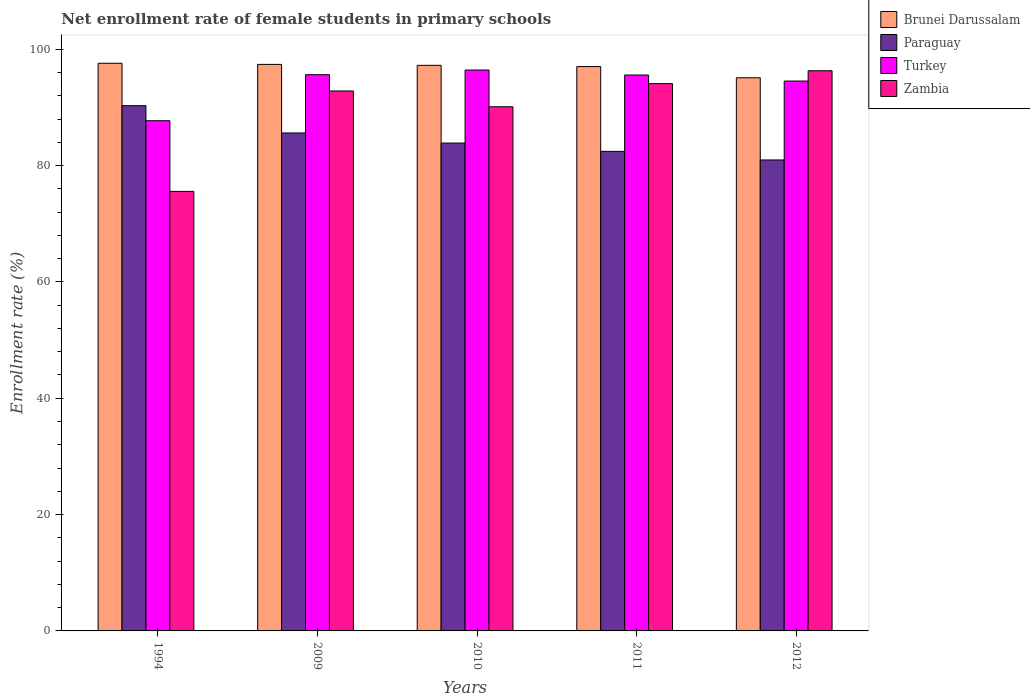How many different coloured bars are there?
Make the answer very short. 4. How many bars are there on the 2nd tick from the left?
Ensure brevity in your answer.  4. How many bars are there on the 4th tick from the right?
Offer a terse response. 4. What is the label of the 4th group of bars from the left?
Give a very brief answer. 2011. In how many cases, is the number of bars for a given year not equal to the number of legend labels?
Keep it short and to the point. 0. What is the net enrollment rate of female students in primary schools in Brunei Darussalam in 2011?
Your response must be concise. 97.02. Across all years, what is the maximum net enrollment rate of female students in primary schools in Zambia?
Your answer should be compact. 96.3. Across all years, what is the minimum net enrollment rate of female students in primary schools in Turkey?
Provide a succinct answer. 87.71. In which year was the net enrollment rate of female students in primary schools in Paraguay maximum?
Your answer should be compact. 1994. What is the total net enrollment rate of female students in primary schools in Brunei Darussalam in the graph?
Keep it short and to the point. 484.35. What is the difference between the net enrollment rate of female students in primary schools in Zambia in 2009 and that in 2010?
Keep it short and to the point. 2.72. What is the difference between the net enrollment rate of female students in primary schools in Zambia in 2010 and the net enrollment rate of female students in primary schools in Brunei Darussalam in 2009?
Provide a succinct answer. -7.28. What is the average net enrollment rate of female students in primary schools in Brunei Darussalam per year?
Ensure brevity in your answer.  96.87. In the year 2012, what is the difference between the net enrollment rate of female students in primary schools in Turkey and net enrollment rate of female students in primary schools in Zambia?
Your response must be concise. -1.77. In how many years, is the net enrollment rate of female students in primary schools in Paraguay greater than 12 %?
Your answer should be compact. 5. What is the ratio of the net enrollment rate of female students in primary schools in Brunei Darussalam in 2011 to that in 2012?
Offer a very short reply. 1.02. What is the difference between the highest and the second highest net enrollment rate of female students in primary schools in Paraguay?
Your answer should be compact. 4.69. What is the difference between the highest and the lowest net enrollment rate of female students in primary schools in Turkey?
Provide a short and direct response. 8.72. In how many years, is the net enrollment rate of female students in primary schools in Brunei Darussalam greater than the average net enrollment rate of female students in primary schools in Brunei Darussalam taken over all years?
Offer a terse response. 4. Is the sum of the net enrollment rate of female students in primary schools in Zambia in 1994 and 2010 greater than the maximum net enrollment rate of female students in primary schools in Brunei Darussalam across all years?
Provide a succinct answer. Yes. Is it the case that in every year, the sum of the net enrollment rate of female students in primary schools in Turkey and net enrollment rate of female students in primary schools in Zambia is greater than the sum of net enrollment rate of female students in primary schools in Paraguay and net enrollment rate of female students in primary schools in Brunei Darussalam?
Offer a very short reply. No. What does the 4th bar from the left in 2009 represents?
Offer a very short reply. Zambia. What does the 2nd bar from the right in 2010 represents?
Provide a succinct answer. Turkey. How many bars are there?
Provide a short and direct response. 20. Are all the bars in the graph horizontal?
Give a very brief answer. No. Does the graph contain any zero values?
Ensure brevity in your answer.  No. Does the graph contain grids?
Offer a very short reply. No. Where does the legend appear in the graph?
Ensure brevity in your answer.  Top right. How many legend labels are there?
Provide a succinct answer. 4. What is the title of the graph?
Make the answer very short. Net enrollment rate of female students in primary schools. Does "Kuwait" appear as one of the legend labels in the graph?
Offer a terse response. No. What is the label or title of the X-axis?
Offer a terse response. Years. What is the label or title of the Y-axis?
Give a very brief answer. Enrollment rate (%). What is the Enrollment rate (%) in Brunei Darussalam in 1994?
Offer a terse response. 97.59. What is the Enrollment rate (%) in Paraguay in 1994?
Your answer should be compact. 90.3. What is the Enrollment rate (%) in Turkey in 1994?
Your response must be concise. 87.71. What is the Enrollment rate (%) in Zambia in 1994?
Your response must be concise. 75.57. What is the Enrollment rate (%) in Brunei Darussalam in 2009?
Make the answer very short. 97.4. What is the Enrollment rate (%) of Paraguay in 2009?
Make the answer very short. 85.61. What is the Enrollment rate (%) in Turkey in 2009?
Give a very brief answer. 95.63. What is the Enrollment rate (%) in Zambia in 2009?
Offer a terse response. 92.83. What is the Enrollment rate (%) in Brunei Darussalam in 2010?
Offer a terse response. 97.24. What is the Enrollment rate (%) in Paraguay in 2010?
Ensure brevity in your answer.  83.87. What is the Enrollment rate (%) in Turkey in 2010?
Ensure brevity in your answer.  96.43. What is the Enrollment rate (%) of Zambia in 2010?
Offer a terse response. 90.11. What is the Enrollment rate (%) in Brunei Darussalam in 2011?
Offer a terse response. 97.02. What is the Enrollment rate (%) in Paraguay in 2011?
Ensure brevity in your answer.  82.44. What is the Enrollment rate (%) in Turkey in 2011?
Offer a terse response. 95.57. What is the Enrollment rate (%) in Zambia in 2011?
Provide a short and direct response. 94.09. What is the Enrollment rate (%) of Brunei Darussalam in 2012?
Your answer should be compact. 95.1. What is the Enrollment rate (%) in Paraguay in 2012?
Offer a terse response. 80.97. What is the Enrollment rate (%) in Turkey in 2012?
Keep it short and to the point. 94.53. What is the Enrollment rate (%) in Zambia in 2012?
Keep it short and to the point. 96.3. Across all years, what is the maximum Enrollment rate (%) in Brunei Darussalam?
Give a very brief answer. 97.59. Across all years, what is the maximum Enrollment rate (%) in Paraguay?
Keep it short and to the point. 90.3. Across all years, what is the maximum Enrollment rate (%) of Turkey?
Offer a very short reply. 96.43. Across all years, what is the maximum Enrollment rate (%) in Zambia?
Offer a terse response. 96.3. Across all years, what is the minimum Enrollment rate (%) in Brunei Darussalam?
Your answer should be very brief. 95.1. Across all years, what is the minimum Enrollment rate (%) in Paraguay?
Ensure brevity in your answer.  80.97. Across all years, what is the minimum Enrollment rate (%) of Turkey?
Provide a short and direct response. 87.71. Across all years, what is the minimum Enrollment rate (%) of Zambia?
Provide a succinct answer. 75.57. What is the total Enrollment rate (%) in Brunei Darussalam in the graph?
Offer a very short reply. 484.35. What is the total Enrollment rate (%) of Paraguay in the graph?
Offer a terse response. 423.2. What is the total Enrollment rate (%) in Turkey in the graph?
Provide a succinct answer. 469.87. What is the total Enrollment rate (%) of Zambia in the graph?
Your answer should be very brief. 448.9. What is the difference between the Enrollment rate (%) of Brunei Darussalam in 1994 and that in 2009?
Provide a succinct answer. 0.2. What is the difference between the Enrollment rate (%) of Paraguay in 1994 and that in 2009?
Your answer should be compact. 4.69. What is the difference between the Enrollment rate (%) of Turkey in 1994 and that in 2009?
Your response must be concise. -7.91. What is the difference between the Enrollment rate (%) in Zambia in 1994 and that in 2009?
Provide a succinct answer. -17.26. What is the difference between the Enrollment rate (%) in Brunei Darussalam in 1994 and that in 2010?
Your answer should be very brief. 0.36. What is the difference between the Enrollment rate (%) of Paraguay in 1994 and that in 2010?
Give a very brief answer. 6.43. What is the difference between the Enrollment rate (%) of Turkey in 1994 and that in 2010?
Your response must be concise. -8.72. What is the difference between the Enrollment rate (%) of Zambia in 1994 and that in 2010?
Provide a short and direct response. -14.55. What is the difference between the Enrollment rate (%) of Brunei Darussalam in 1994 and that in 2011?
Your answer should be compact. 0.57. What is the difference between the Enrollment rate (%) in Paraguay in 1994 and that in 2011?
Give a very brief answer. 7.86. What is the difference between the Enrollment rate (%) of Turkey in 1994 and that in 2011?
Your answer should be very brief. -7.86. What is the difference between the Enrollment rate (%) of Zambia in 1994 and that in 2011?
Keep it short and to the point. -18.53. What is the difference between the Enrollment rate (%) of Brunei Darussalam in 1994 and that in 2012?
Your answer should be very brief. 2.49. What is the difference between the Enrollment rate (%) of Paraguay in 1994 and that in 2012?
Make the answer very short. 9.34. What is the difference between the Enrollment rate (%) of Turkey in 1994 and that in 2012?
Give a very brief answer. -6.82. What is the difference between the Enrollment rate (%) in Zambia in 1994 and that in 2012?
Make the answer very short. -20.74. What is the difference between the Enrollment rate (%) of Brunei Darussalam in 2009 and that in 2010?
Keep it short and to the point. 0.16. What is the difference between the Enrollment rate (%) of Paraguay in 2009 and that in 2010?
Your answer should be compact. 1.74. What is the difference between the Enrollment rate (%) in Turkey in 2009 and that in 2010?
Your answer should be very brief. -0.8. What is the difference between the Enrollment rate (%) in Zambia in 2009 and that in 2010?
Your answer should be compact. 2.72. What is the difference between the Enrollment rate (%) of Brunei Darussalam in 2009 and that in 2011?
Your response must be concise. 0.38. What is the difference between the Enrollment rate (%) in Paraguay in 2009 and that in 2011?
Your response must be concise. 3.17. What is the difference between the Enrollment rate (%) in Turkey in 2009 and that in 2011?
Offer a terse response. 0.06. What is the difference between the Enrollment rate (%) in Zambia in 2009 and that in 2011?
Keep it short and to the point. -1.26. What is the difference between the Enrollment rate (%) in Brunei Darussalam in 2009 and that in 2012?
Your answer should be compact. 2.3. What is the difference between the Enrollment rate (%) in Paraguay in 2009 and that in 2012?
Your response must be concise. 4.64. What is the difference between the Enrollment rate (%) in Turkey in 2009 and that in 2012?
Provide a short and direct response. 1.1. What is the difference between the Enrollment rate (%) in Zambia in 2009 and that in 2012?
Offer a very short reply. -3.48. What is the difference between the Enrollment rate (%) in Brunei Darussalam in 2010 and that in 2011?
Your answer should be compact. 0.21. What is the difference between the Enrollment rate (%) of Paraguay in 2010 and that in 2011?
Ensure brevity in your answer.  1.43. What is the difference between the Enrollment rate (%) in Turkey in 2010 and that in 2011?
Make the answer very short. 0.86. What is the difference between the Enrollment rate (%) of Zambia in 2010 and that in 2011?
Offer a very short reply. -3.98. What is the difference between the Enrollment rate (%) of Brunei Darussalam in 2010 and that in 2012?
Give a very brief answer. 2.13. What is the difference between the Enrollment rate (%) in Paraguay in 2010 and that in 2012?
Your response must be concise. 2.91. What is the difference between the Enrollment rate (%) in Turkey in 2010 and that in 2012?
Provide a succinct answer. 1.9. What is the difference between the Enrollment rate (%) of Zambia in 2010 and that in 2012?
Provide a short and direct response. -6.19. What is the difference between the Enrollment rate (%) of Brunei Darussalam in 2011 and that in 2012?
Offer a terse response. 1.92. What is the difference between the Enrollment rate (%) of Paraguay in 2011 and that in 2012?
Ensure brevity in your answer.  1.48. What is the difference between the Enrollment rate (%) in Turkey in 2011 and that in 2012?
Give a very brief answer. 1.04. What is the difference between the Enrollment rate (%) of Zambia in 2011 and that in 2012?
Offer a terse response. -2.21. What is the difference between the Enrollment rate (%) of Brunei Darussalam in 1994 and the Enrollment rate (%) of Paraguay in 2009?
Keep it short and to the point. 11.98. What is the difference between the Enrollment rate (%) of Brunei Darussalam in 1994 and the Enrollment rate (%) of Turkey in 2009?
Give a very brief answer. 1.97. What is the difference between the Enrollment rate (%) in Brunei Darussalam in 1994 and the Enrollment rate (%) in Zambia in 2009?
Your answer should be compact. 4.76. What is the difference between the Enrollment rate (%) in Paraguay in 1994 and the Enrollment rate (%) in Turkey in 2009?
Provide a short and direct response. -5.33. What is the difference between the Enrollment rate (%) in Paraguay in 1994 and the Enrollment rate (%) in Zambia in 2009?
Provide a short and direct response. -2.53. What is the difference between the Enrollment rate (%) of Turkey in 1994 and the Enrollment rate (%) of Zambia in 2009?
Offer a very short reply. -5.12. What is the difference between the Enrollment rate (%) of Brunei Darussalam in 1994 and the Enrollment rate (%) of Paraguay in 2010?
Your answer should be very brief. 13.72. What is the difference between the Enrollment rate (%) of Brunei Darussalam in 1994 and the Enrollment rate (%) of Turkey in 2010?
Offer a very short reply. 1.16. What is the difference between the Enrollment rate (%) of Brunei Darussalam in 1994 and the Enrollment rate (%) of Zambia in 2010?
Provide a succinct answer. 7.48. What is the difference between the Enrollment rate (%) of Paraguay in 1994 and the Enrollment rate (%) of Turkey in 2010?
Provide a short and direct response. -6.13. What is the difference between the Enrollment rate (%) in Paraguay in 1994 and the Enrollment rate (%) in Zambia in 2010?
Provide a succinct answer. 0.19. What is the difference between the Enrollment rate (%) of Turkey in 1994 and the Enrollment rate (%) of Zambia in 2010?
Provide a succinct answer. -2.4. What is the difference between the Enrollment rate (%) of Brunei Darussalam in 1994 and the Enrollment rate (%) of Paraguay in 2011?
Provide a succinct answer. 15.15. What is the difference between the Enrollment rate (%) of Brunei Darussalam in 1994 and the Enrollment rate (%) of Turkey in 2011?
Offer a very short reply. 2.02. What is the difference between the Enrollment rate (%) of Brunei Darussalam in 1994 and the Enrollment rate (%) of Zambia in 2011?
Provide a succinct answer. 3.5. What is the difference between the Enrollment rate (%) of Paraguay in 1994 and the Enrollment rate (%) of Turkey in 2011?
Your response must be concise. -5.27. What is the difference between the Enrollment rate (%) of Paraguay in 1994 and the Enrollment rate (%) of Zambia in 2011?
Your response must be concise. -3.79. What is the difference between the Enrollment rate (%) of Turkey in 1994 and the Enrollment rate (%) of Zambia in 2011?
Provide a succinct answer. -6.38. What is the difference between the Enrollment rate (%) in Brunei Darussalam in 1994 and the Enrollment rate (%) in Paraguay in 2012?
Offer a very short reply. 16.63. What is the difference between the Enrollment rate (%) in Brunei Darussalam in 1994 and the Enrollment rate (%) in Turkey in 2012?
Ensure brevity in your answer.  3.06. What is the difference between the Enrollment rate (%) of Brunei Darussalam in 1994 and the Enrollment rate (%) of Zambia in 2012?
Give a very brief answer. 1.29. What is the difference between the Enrollment rate (%) of Paraguay in 1994 and the Enrollment rate (%) of Turkey in 2012?
Your response must be concise. -4.23. What is the difference between the Enrollment rate (%) in Paraguay in 1994 and the Enrollment rate (%) in Zambia in 2012?
Your answer should be very brief. -6. What is the difference between the Enrollment rate (%) of Turkey in 1994 and the Enrollment rate (%) of Zambia in 2012?
Your response must be concise. -8.59. What is the difference between the Enrollment rate (%) of Brunei Darussalam in 2009 and the Enrollment rate (%) of Paraguay in 2010?
Provide a succinct answer. 13.52. What is the difference between the Enrollment rate (%) of Brunei Darussalam in 2009 and the Enrollment rate (%) of Turkey in 2010?
Offer a very short reply. 0.97. What is the difference between the Enrollment rate (%) in Brunei Darussalam in 2009 and the Enrollment rate (%) in Zambia in 2010?
Offer a terse response. 7.28. What is the difference between the Enrollment rate (%) in Paraguay in 2009 and the Enrollment rate (%) in Turkey in 2010?
Give a very brief answer. -10.82. What is the difference between the Enrollment rate (%) in Paraguay in 2009 and the Enrollment rate (%) in Zambia in 2010?
Provide a succinct answer. -4.5. What is the difference between the Enrollment rate (%) in Turkey in 2009 and the Enrollment rate (%) in Zambia in 2010?
Your answer should be very brief. 5.52. What is the difference between the Enrollment rate (%) of Brunei Darussalam in 2009 and the Enrollment rate (%) of Paraguay in 2011?
Offer a terse response. 14.95. What is the difference between the Enrollment rate (%) of Brunei Darussalam in 2009 and the Enrollment rate (%) of Turkey in 2011?
Provide a short and direct response. 1.83. What is the difference between the Enrollment rate (%) of Brunei Darussalam in 2009 and the Enrollment rate (%) of Zambia in 2011?
Give a very brief answer. 3.3. What is the difference between the Enrollment rate (%) of Paraguay in 2009 and the Enrollment rate (%) of Turkey in 2011?
Keep it short and to the point. -9.96. What is the difference between the Enrollment rate (%) in Paraguay in 2009 and the Enrollment rate (%) in Zambia in 2011?
Give a very brief answer. -8.48. What is the difference between the Enrollment rate (%) of Turkey in 2009 and the Enrollment rate (%) of Zambia in 2011?
Your answer should be very brief. 1.54. What is the difference between the Enrollment rate (%) in Brunei Darussalam in 2009 and the Enrollment rate (%) in Paraguay in 2012?
Provide a succinct answer. 16.43. What is the difference between the Enrollment rate (%) of Brunei Darussalam in 2009 and the Enrollment rate (%) of Turkey in 2012?
Offer a terse response. 2.86. What is the difference between the Enrollment rate (%) of Brunei Darussalam in 2009 and the Enrollment rate (%) of Zambia in 2012?
Ensure brevity in your answer.  1.09. What is the difference between the Enrollment rate (%) in Paraguay in 2009 and the Enrollment rate (%) in Turkey in 2012?
Offer a very short reply. -8.92. What is the difference between the Enrollment rate (%) of Paraguay in 2009 and the Enrollment rate (%) of Zambia in 2012?
Offer a terse response. -10.7. What is the difference between the Enrollment rate (%) of Turkey in 2009 and the Enrollment rate (%) of Zambia in 2012?
Provide a succinct answer. -0.68. What is the difference between the Enrollment rate (%) of Brunei Darussalam in 2010 and the Enrollment rate (%) of Paraguay in 2011?
Provide a short and direct response. 14.79. What is the difference between the Enrollment rate (%) in Brunei Darussalam in 2010 and the Enrollment rate (%) in Turkey in 2011?
Keep it short and to the point. 1.67. What is the difference between the Enrollment rate (%) of Brunei Darussalam in 2010 and the Enrollment rate (%) of Zambia in 2011?
Ensure brevity in your answer.  3.14. What is the difference between the Enrollment rate (%) of Paraguay in 2010 and the Enrollment rate (%) of Turkey in 2011?
Ensure brevity in your answer.  -11.7. What is the difference between the Enrollment rate (%) in Paraguay in 2010 and the Enrollment rate (%) in Zambia in 2011?
Your answer should be compact. -10.22. What is the difference between the Enrollment rate (%) of Turkey in 2010 and the Enrollment rate (%) of Zambia in 2011?
Offer a terse response. 2.34. What is the difference between the Enrollment rate (%) in Brunei Darussalam in 2010 and the Enrollment rate (%) in Paraguay in 2012?
Your answer should be very brief. 16.27. What is the difference between the Enrollment rate (%) of Brunei Darussalam in 2010 and the Enrollment rate (%) of Turkey in 2012?
Your answer should be very brief. 2.7. What is the difference between the Enrollment rate (%) in Brunei Darussalam in 2010 and the Enrollment rate (%) in Zambia in 2012?
Offer a very short reply. 0.93. What is the difference between the Enrollment rate (%) in Paraguay in 2010 and the Enrollment rate (%) in Turkey in 2012?
Provide a short and direct response. -10.66. What is the difference between the Enrollment rate (%) of Paraguay in 2010 and the Enrollment rate (%) of Zambia in 2012?
Ensure brevity in your answer.  -12.43. What is the difference between the Enrollment rate (%) of Turkey in 2010 and the Enrollment rate (%) of Zambia in 2012?
Offer a very short reply. 0.13. What is the difference between the Enrollment rate (%) in Brunei Darussalam in 2011 and the Enrollment rate (%) in Paraguay in 2012?
Offer a very short reply. 16.05. What is the difference between the Enrollment rate (%) in Brunei Darussalam in 2011 and the Enrollment rate (%) in Turkey in 2012?
Provide a short and direct response. 2.49. What is the difference between the Enrollment rate (%) in Brunei Darussalam in 2011 and the Enrollment rate (%) in Zambia in 2012?
Your answer should be compact. 0.72. What is the difference between the Enrollment rate (%) of Paraguay in 2011 and the Enrollment rate (%) of Turkey in 2012?
Make the answer very short. -12.09. What is the difference between the Enrollment rate (%) in Paraguay in 2011 and the Enrollment rate (%) in Zambia in 2012?
Make the answer very short. -13.86. What is the difference between the Enrollment rate (%) in Turkey in 2011 and the Enrollment rate (%) in Zambia in 2012?
Your answer should be compact. -0.74. What is the average Enrollment rate (%) in Brunei Darussalam per year?
Make the answer very short. 96.87. What is the average Enrollment rate (%) in Paraguay per year?
Provide a succinct answer. 84.64. What is the average Enrollment rate (%) of Turkey per year?
Your answer should be compact. 93.97. What is the average Enrollment rate (%) in Zambia per year?
Your answer should be compact. 89.78. In the year 1994, what is the difference between the Enrollment rate (%) in Brunei Darussalam and Enrollment rate (%) in Paraguay?
Offer a very short reply. 7.29. In the year 1994, what is the difference between the Enrollment rate (%) of Brunei Darussalam and Enrollment rate (%) of Turkey?
Make the answer very short. 9.88. In the year 1994, what is the difference between the Enrollment rate (%) in Brunei Darussalam and Enrollment rate (%) in Zambia?
Your answer should be very brief. 22.03. In the year 1994, what is the difference between the Enrollment rate (%) of Paraguay and Enrollment rate (%) of Turkey?
Offer a terse response. 2.59. In the year 1994, what is the difference between the Enrollment rate (%) of Paraguay and Enrollment rate (%) of Zambia?
Ensure brevity in your answer.  14.74. In the year 1994, what is the difference between the Enrollment rate (%) of Turkey and Enrollment rate (%) of Zambia?
Your response must be concise. 12.15. In the year 2009, what is the difference between the Enrollment rate (%) of Brunei Darussalam and Enrollment rate (%) of Paraguay?
Your answer should be very brief. 11.79. In the year 2009, what is the difference between the Enrollment rate (%) in Brunei Darussalam and Enrollment rate (%) in Turkey?
Offer a terse response. 1.77. In the year 2009, what is the difference between the Enrollment rate (%) of Brunei Darussalam and Enrollment rate (%) of Zambia?
Provide a succinct answer. 4.57. In the year 2009, what is the difference between the Enrollment rate (%) of Paraguay and Enrollment rate (%) of Turkey?
Make the answer very short. -10.02. In the year 2009, what is the difference between the Enrollment rate (%) of Paraguay and Enrollment rate (%) of Zambia?
Ensure brevity in your answer.  -7.22. In the year 2009, what is the difference between the Enrollment rate (%) of Turkey and Enrollment rate (%) of Zambia?
Offer a very short reply. 2.8. In the year 2010, what is the difference between the Enrollment rate (%) of Brunei Darussalam and Enrollment rate (%) of Paraguay?
Make the answer very short. 13.36. In the year 2010, what is the difference between the Enrollment rate (%) in Brunei Darussalam and Enrollment rate (%) in Turkey?
Your response must be concise. 0.8. In the year 2010, what is the difference between the Enrollment rate (%) in Brunei Darussalam and Enrollment rate (%) in Zambia?
Provide a succinct answer. 7.12. In the year 2010, what is the difference between the Enrollment rate (%) of Paraguay and Enrollment rate (%) of Turkey?
Offer a terse response. -12.56. In the year 2010, what is the difference between the Enrollment rate (%) in Paraguay and Enrollment rate (%) in Zambia?
Offer a very short reply. -6.24. In the year 2010, what is the difference between the Enrollment rate (%) in Turkey and Enrollment rate (%) in Zambia?
Provide a short and direct response. 6.32. In the year 2011, what is the difference between the Enrollment rate (%) in Brunei Darussalam and Enrollment rate (%) in Paraguay?
Provide a short and direct response. 14.58. In the year 2011, what is the difference between the Enrollment rate (%) of Brunei Darussalam and Enrollment rate (%) of Turkey?
Your answer should be compact. 1.45. In the year 2011, what is the difference between the Enrollment rate (%) of Brunei Darussalam and Enrollment rate (%) of Zambia?
Give a very brief answer. 2.93. In the year 2011, what is the difference between the Enrollment rate (%) of Paraguay and Enrollment rate (%) of Turkey?
Provide a short and direct response. -13.12. In the year 2011, what is the difference between the Enrollment rate (%) in Paraguay and Enrollment rate (%) in Zambia?
Your answer should be very brief. -11.65. In the year 2011, what is the difference between the Enrollment rate (%) in Turkey and Enrollment rate (%) in Zambia?
Provide a short and direct response. 1.48. In the year 2012, what is the difference between the Enrollment rate (%) in Brunei Darussalam and Enrollment rate (%) in Paraguay?
Offer a very short reply. 14.13. In the year 2012, what is the difference between the Enrollment rate (%) in Brunei Darussalam and Enrollment rate (%) in Turkey?
Give a very brief answer. 0.57. In the year 2012, what is the difference between the Enrollment rate (%) in Brunei Darussalam and Enrollment rate (%) in Zambia?
Make the answer very short. -1.2. In the year 2012, what is the difference between the Enrollment rate (%) of Paraguay and Enrollment rate (%) of Turkey?
Your response must be concise. -13.57. In the year 2012, what is the difference between the Enrollment rate (%) in Paraguay and Enrollment rate (%) in Zambia?
Your response must be concise. -15.34. In the year 2012, what is the difference between the Enrollment rate (%) in Turkey and Enrollment rate (%) in Zambia?
Provide a succinct answer. -1.77. What is the ratio of the Enrollment rate (%) of Brunei Darussalam in 1994 to that in 2009?
Offer a very short reply. 1. What is the ratio of the Enrollment rate (%) of Paraguay in 1994 to that in 2009?
Your answer should be very brief. 1.05. What is the ratio of the Enrollment rate (%) of Turkey in 1994 to that in 2009?
Keep it short and to the point. 0.92. What is the ratio of the Enrollment rate (%) in Zambia in 1994 to that in 2009?
Offer a very short reply. 0.81. What is the ratio of the Enrollment rate (%) in Brunei Darussalam in 1994 to that in 2010?
Offer a terse response. 1. What is the ratio of the Enrollment rate (%) of Paraguay in 1994 to that in 2010?
Offer a terse response. 1.08. What is the ratio of the Enrollment rate (%) of Turkey in 1994 to that in 2010?
Give a very brief answer. 0.91. What is the ratio of the Enrollment rate (%) in Zambia in 1994 to that in 2010?
Provide a succinct answer. 0.84. What is the ratio of the Enrollment rate (%) in Brunei Darussalam in 1994 to that in 2011?
Offer a terse response. 1.01. What is the ratio of the Enrollment rate (%) in Paraguay in 1994 to that in 2011?
Offer a terse response. 1.1. What is the ratio of the Enrollment rate (%) in Turkey in 1994 to that in 2011?
Offer a very short reply. 0.92. What is the ratio of the Enrollment rate (%) of Zambia in 1994 to that in 2011?
Provide a succinct answer. 0.8. What is the ratio of the Enrollment rate (%) of Brunei Darussalam in 1994 to that in 2012?
Give a very brief answer. 1.03. What is the ratio of the Enrollment rate (%) of Paraguay in 1994 to that in 2012?
Offer a terse response. 1.12. What is the ratio of the Enrollment rate (%) of Turkey in 1994 to that in 2012?
Make the answer very short. 0.93. What is the ratio of the Enrollment rate (%) of Zambia in 1994 to that in 2012?
Provide a succinct answer. 0.78. What is the ratio of the Enrollment rate (%) in Brunei Darussalam in 2009 to that in 2010?
Keep it short and to the point. 1. What is the ratio of the Enrollment rate (%) in Paraguay in 2009 to that in 2010?
Provide a short and direct response. 1.02. What is the ratio of the Enrollment rate (%) of Turkey in 2009 to that in 2010?
Offer a very short reply. 0.99. What is the ratio of the Enrollment rate (%) in Zambia in 2009 to that in 2010?
Give a very brief answer. 1.03. What is the ratio of the Enrollment rate (%) of Brunei Darussalam in 2009 to that in 2011?
Provide a succinct answer. 1. What is the ratio of the Enrollment rate (%) in Paraguay in 2009 to that in 2011?
Your answer should be compact. 1.04. What is the ratio of the Enrollment rate (%) in Zambia in 2009 to that in 2011?
Provide a short and direct response. 0.99. What is the ratio of the Enrollment rate (%) in Brunei Darussalam in 2009 to that in 2012?
Provide a succinct answer. 1.02. What is the ratio of the Enrollment rate (%) in Paraguay in 2009 to that in 2012?
Keep it short and to the point. 1.06. What is the ratio of the Enrollment rate (%) of Turkey in 2009 to that in 2012?
Make the answer very short. 1.01. What is the ratio of the Enrollment rate (%) in Zambia in 2009 to that in 2012?
Give a very brief answer. 0.96. What is the ratio of the Enrollment rate (%) of Paraguay in 2010 to that in 2011?
Offer a terse response. 1.02. What is the ratio of the Enrollment rate (%) of Turkey in 2010 to that in 2011?
Provide a short and direct response. 1.01. What is the ratio of the Enrollment rate (%) of Zambia in 2010 to that in 2011?
Keep it short and to the point. 0.96. What is the ratio of the Enrollment rate (%) of Brunei Darussalam in 2010 to that in 2012?
Ensure brevity in your answer.  1.02. What is the ratio of the Enrollment rate (%) of Paraguay in 2010 to that in 2012?
Your answer should be compact. 1.04. What is the ratio of the Enrollment rate (%) in Turkey in 2010 to that in 2012?
Provide a succinct answer. 1.02. What is the ratio of the Enrollment rate (%) of Zambia in 2010 to that in 2012?
Your answer should be very brief. 0.94. What is the ratio of the Enrollment rate (%) of Brunei Darussalam in 2011 to that in 2012?
Give a very brief answer. 1.02. What is the ratio of the Enrollment rate (%) of Paraguay in 2011 to that in 2012?
Your answer should be very brief. 1.02. What is the ratio of the Enrollment rate (%) in Turkey in 2011 to that in 2012?
Give a very brief answer. 1.01. What is the ratio of the Enrollment rate (%) of Zambia in 2011 to that in 2012?
Offer a terse response. 0.98. What is the difference between the highest and the second highest Enrollment rate (%) of Brunei Darussalam?
Ensure brevity in your answer.  0.2. What is the difference between the highest and the second highest Enrollment rate (%) of Paraguay?
Provide a succinct answer. 4.69. What is the difference between the highest and the second highest Enrollment rate (%) of Turkey?
Ensure brevity in your answer.  0.8. What is the difference between the highest and the second highest Enrollment rate (%) of Zambia?
Offer a very short reply. 2.21. What is the difference between the highest and the lowest Enrollment rate (%) of Brunei Darussalam?
Give a very brief answer. 2.49. What is the difference between the highest and the lowest Enrollment rate (%) of Paraguay?
Your answer should be compact. 9.34. What is the difference between the highest and the lowest Enrollment rate (%) of Turkey?
Ensure brevity in your answer.  8.72. What is the difference between the highest and the lowest Enrollment rate (%) in Zambia?
Your answer should be very brief. 20.74. 